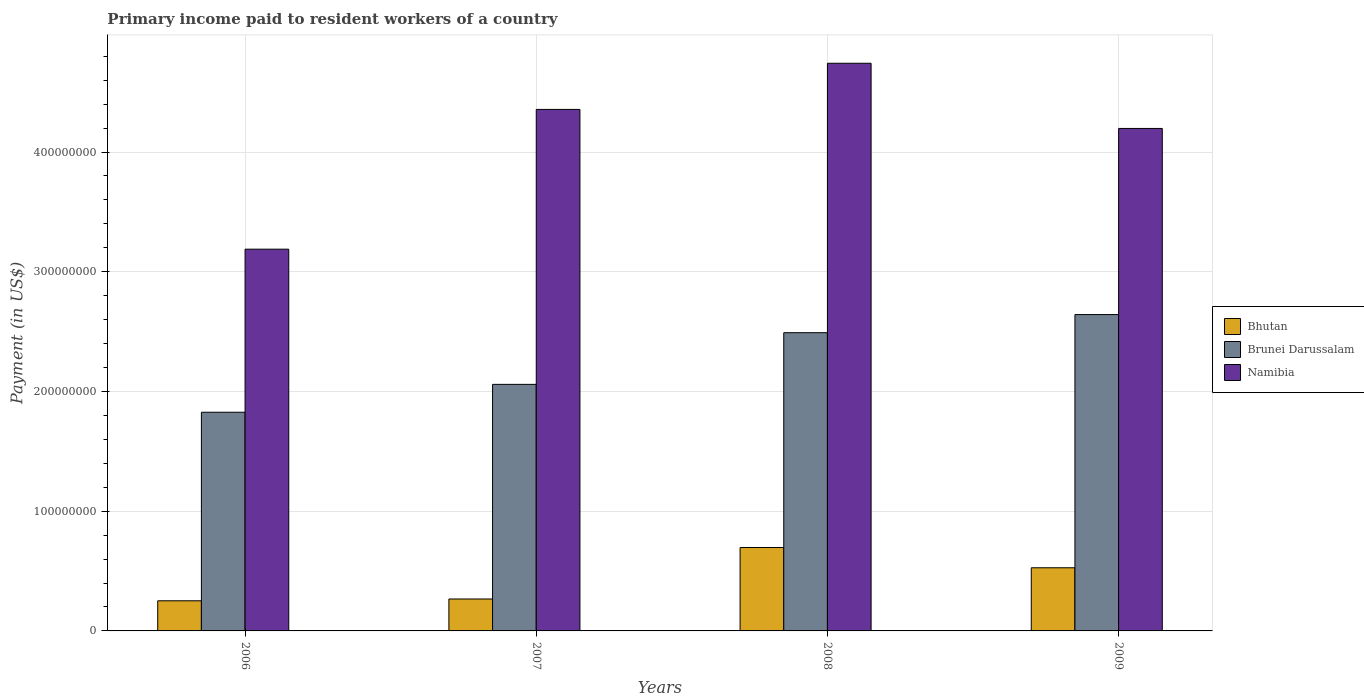How many groups of bars are there?
Keep it short and to the point. 4. Are the number of bars on each tick of the X-axis equal?
Give a very brief answer. Yes. How many bars are there on the 3rd tick from the right?
Your answer should be very brief. 3. In how many cases, is the number of bars for a given year not equal to the number of legend labels?
Your response must be concise. 0. What is the amount paid to workers in Bhutan in 2009?
Provide a short and direct response. 5.27e+07. Across all years, what is the maximum amount paid to workers in Bhutan?
Ensure brevity in your answer.  6.97e+07. Across all years, what is the minimum amount paid to workers in Bhutan?
Make the answer very short. 2.52e+07. What is the total amount paid to workers in Brunei Darussalam in the graph?
Keep it short and to the point. 9.02e+08. What is the difference between the amount paid to workers in Namibia in 2007 and that in 2009?
Keep it short and to the point. 1.59e+07. What is the difference between the amount paid to workers in Bhutan in 2007 and the amount paid to workers in Brunei Darussalam in 2008?
Give a very brief answer. -2.22e+08. What is the average amount paid to workers in Namibia per year?
Your answer should be compact. 4.12e+08. In the year 2007, what is the difference between the amount paid to workers in Bhutan and amount paid to workers in Brunei Darussalam?
Ensure brevity in your answer.  -1.79e+08. In how many years, is the amount paid to workers in Namibia greater than 380000000 US$?
Make the answer very short. 3. What is the ratio of the amount paid to workers in Brunei Darussalam in 2007 to that in 2008?
Provide a short and direct response. 0.83. Is the amount paid to workers in Brunei Darussalam in 2008 less than that in 2009?
Offer a very short reply. Yes. Is the difference between the amount paid to workers in Bhutan in 2006 and 2009 greater than the difference between the amount paid to workers in Brunei Darussalam in 2006 and 2009?
Make the answer very short. Yes. What is the difference between the highest and the second highest amount paid to workers in Namibia?
Your answer should be very brief. 3.86e+07. What is the difference between the highest and the lowest amount paid to workers in Bhutan?
Keep it short and to the point. 4.45e+07. What does the 3rd bar from the left in 2009 represents?
Offer a very short reply. Namibia. What does the 1st bar from the right in 2008 represents?
Your response must be concise. Namibia. Is it the case that in every year, the sum of the amount paid to workers in Namibia and amount paid to workers in Bhutan is greater than the amount paid to workers in Brunei Darussalam?
Provide a succinct answer. Yes. Are all the bars in the graph horizontal?
Make the answer very short. No. How many years are there in the graph?
Your answer should be very brief. 4. What is the difference between two consecutive major ticks on the Y-axis?
Provide a succinct answer. 1.00e+08. Does the graph contain any zero values?
Your response must be concise. No. Does the graph contain grids?
Your answer should be very brief. Yes. How many legend labels are there?
Keep it short and to the point. 3. What is the title of the graph?
Give a very brief answer. Primary income paid to resident workers of a country. What is the label or title of the X-axis?
Your answer should be compact. Years. What is the label or title of the Y-axis?
Give a very brief answer. Payment (in US$). What is the Payment (in US$) of Bhutan in 2006?
Offer a terse response. 2.52e+07. What is the Payment (in US$) in Brunei Darussalam in 2006?
Offer a terse response. 1.83e+08. What is the Payment (in US$) in Namibia in 2006?
Provide a succinct answer. 3.19e+08. What is the Payment (in US$) in Bhutan in 2007?
Keep it short and to the point. 2.67e+07. What is the Payment (in US$) of Brunei Darussalam in 2007?
Keep it short and to the point. 2.06e+08. What is the Payment (in US$) in Namibia in 2007?
Offer a very short reply. 4.36e+08. What is the Payment (in US$) of Bhutan in 2008?
Offer a terse response. 6.97e+07. What is the Payment (in US$) of Brunei Darussalam in 2008?
Make the answer very short. 2.49e+08. What is the Payment (in US$) of Namibia in 2008?
Make the answer very short. 4.74e+08. What is the Payment (in US$) of Bhutan in 2009?
Keep it short and to the point. 5.27e+07. What is the Payment (in US$) in Brunei Darussalam in 2009?
Offer a terse response. 2.64e+08. What is the Payment (in US$) in Namibia in 2009?
Make the answer very short. 4.20e+08. Across all years, what is the maximum Payment (in US$) of Bhutan?
Your answer should be very brief. 6.97e+07. Across all years, what is the maximum Payment (in US$) of Brunei Darussalam?
Provide a short and direct response. 2.64e+08. Across all years, what is the maximum Payment (in US$) in Namibia?
Your answer should be very brief. 4.74e+08. Across all years, what is the minimum Payment (in US$) in Bhutan?
Make the answer very short. 2.52e+07. Across all years, what is the minimum Payment (in US$) of Brunei Darussalam?
Your answer should be very brief. 1.83e+08. Across all years, what is the minimum Payment (in US$) in Namibia?
Your response must be concise. 3.19e+08. What is the total Payment (in US$) in Bhutan in the graph?
Your answer should be compact. 1.74e+08. What is the total Payment (in US$) of Brunei Darussalam in the graph?
Provide a short and direct response. 9.02e+08. What is the total Payment (in US$) in Namibia in the graph?
Keep it short and to the point. 1.65e+09. What is the difference between the Payment (in US$) in Bhutan in 2006 and that in 2007?
Your answer should be compact. -1.50e+06. What is the difference between the Payment (in US$) of Brunei Darussalam in 2006 and that in 2007?
Give a very brief answer. -2.33e+07. What is the difference between the Payment (in US$) in Namibia in 2006 and that in 2007?
Ensure brevity in your answer.  -1.17e+08. What is the difference between the Payment (in US$) of Bhutan in 2006 and that in 2008?
Offer a terse response. -4.45e+07. What is the difference between the Payment (in US$) of Brunei Darussalam in 2006 and that in 2008?
Provide a succinct answer. -6.64e+07. What is the difference between the Payment (in US$) in Namibia in 2006 and that in 2008?
Your answer should be compact. -1.55e+08. What is the difference between the Payment (in US$) in Bhutan in 2006 and that in 2009?
Provide a short and direct response. -2.76e+07. What is the difference between the Payment (in US$) in Brunei Darussalam in 2006 and that in 2009?
Give a very brief answer. -8.16e+07. What is the difference between the Payment (in US$) of Namibia in 2006 and that in 2009?
Ensure brevity in your answer.  -1.01e+08. What is the difference between the Payment (in US$) of Bhutan in 2007 and that in 2008?
Your answer should be compact. -4.30e+07. What is the difference between the Payment (in US$) of Brunei Darussalam in 2007 and that in 2008?
Your response must be concise. -4.32e+07. What is the difference between the Payment (in US$) of Namibia in 2007 and that in 2008?
Your answer should be very brief. -3.86e+07. What is the difference between the Payment (in US$) of Bhutan in 2007 and that in 2009?
Offer a very short reply. -2.61e+07. What is the difference between the Payment (in US$) of Brunei Darussalam in 2007 and that in 2009?
Make the answer very short. -5.83e+07. What is the difference between the Payment (in US$) in Namibia in 2007 and that in 2009?
Offer a terse response. 1.59e+07. What is the difference between the Payment (in US$) of Bhutan in 2008 and that in 2009?
Give a very brief answer. 1.69e+07. What is the difference between the Payment (in US$) in Brunei Darussalam in 2008 and that in 2009?
Ensure brevity in your answer.  -1.51e+07. What is the difference between the Payment (in US$) in Namibia in 2008 and that in 2009?
Offer a terse response. 5.45e+07. What is the difference between the Payment (in US$) of Bhutan in 2006 and the Payment (in US$) of Brunei Darussalam in 2007?
Your answer should be very brief. -1.81e+08. What is the difference between the Payment (in US$) of Bhutan in 2006 and the Payment (in US$) of Namibia in 2007?
Offer a terse response. -4.10e+08. What is the difference between the Payment (in US$) of Brunei Darussalam in 2006 and the Payment (in US$) of Namibia in 2007?
Offer a very short reply. -2.53e+08. What is the difference between the Payment (in US$) of Bhutan in 2006 and the Payment (in US$) of Brunei Darussalam in 2008?
Ensure brevity in your answer.  -2.24e+08. What is the difference between the Payment (in US$) of Bhutan in 2006 and the Payment (in US$) of Namibia in 2008?
Provide a succinct answer. -4.49e+08. What is the difference between the Payment (in US$) in Brunei Darussalam in 2006 and the Payment (in US$) in Namibia in 2008?
Keep it short and to the point. -2.92e+08. What is the difference between the Payment (in US$) of Bhutan in 2006 and the Payment (in US$) of Brunei Darussalam in 2009?
Provide a short and direct response. -2.39e+08. What is the difference between the Payment (in US$) in Bhutan in 2006 and the Payment (in US$) in Namibia in 2009?
Provide a succinct answer. -3.95e+08. What is the difference between the Payment (in US$) of Brunei Darussalam in 2006 and the Payment (in US$) of Namibia in 2009?
Ensure brevity in your answer.  -2.37e+08. What is the difference between the Payment (in US$) of Bhutan in 2007 and the Payment (in US$) of Brunei Darussalam in 2008?
Your response must be concise. -2.22e+08. What is the difference between the Payment (in US$) in Bhutan in 2007 and the Payment (in US$) in Namibia in 2008?
Your response must be concise. -4.47e+08. What is the difference between the Payment (in US$) of Brunei Darussalam in 2007 and the Payment (in US$) of Namibia in 2008?
Make the answer very short. -2.68e+08. What is the difference between the Payment (in US$) of Bhutan in 2007 and the Payment (in US$) of Brunei Darussalam in 2009?
Make the answer very short. -2.38e+08. What is the difference between the Payment (in US$) in Bhutan in 2007 and the Payment (in US$) in Namibia in 2009?
Your response must be concise. -3.93e+08. What is the difference between the Payment (in US$) in Brunei Darussalam in 2007 and the Payment (in US$) in Namibia in 2009?
Provide a succinct answer. -2.14e+08. What is the difference between the Payment (in US$) in Bhutan in 2008 and the Payment (in US$) in Brunei Darussalam in 2009?
Your response must be concise. -1.95e+08. What is the difference between the Payment (in US$) in Bhutan in 2008 and the Payment (in US$) in Namibia in 2009?
Offer a terse response. -3.50e+08. What is the difference between the Payment (in US$) of Brunei Darussalam in 2008 and the Payment (in US$) of Namibia in 2009?
Offer a very short reply. -1.71e+08. What is the average Payment (in US$) in Bhutan per year?
Offer a terse response. 4.36e+07. What is the average Payment (in US$) of Brunei Darussalam per year?
Provide a succinct answer. 2.25e+08. What is the average Payment (in US$) in Namibia per year?
Make the answer very short. 4.12e+08. In the year 2006, what is the difference between the Payment (in US$) in Bhutan and Payment (in US$) in Brunei Darussalam?
Your answer should be very brief. -1.57e+08. In the year 2006, what is the difference between the Payment (in US$) in Bhutan and Payment (in US$) in Namibia?
Offer a very short reply. -2.94e+08. In the year 2006, what is the difference between the Payment (in US$) of Brunei Darussalam and Payment (in US$) of Namibia?
Your response must be concise. -1.36e+08. In the year 2007, what is the difference between the Payment (in US$) in Bhutan and Payment (in US$) in Brunei Darussalam?
Offer a very short reply. -1.79e+08. In the year 2007, what is the difference between the Payment (in US$) in Bhutan and Payment (in US$) in Namibia?
Give a very brief answer. -4.09e+08. In the year 2007, what is the difference between the Payment (in US$) in Brunei Darussalam and Payment (in US$) in Namibia?
Ensure brevity in your answer.  -2.30e+08. In the year 2008, what is the difference between the Payment (in US$) of Bhutan and Payment (in US$) of Brunei Darussalam?
Your answer should be very brief. -1.79e+08. In the year 2008, what is the difference between the Payment (in US$) of Bhutan and Payment (in US$) of Namibia?
Keep it short and to the point. -4.05e+08. In the year 2008, what is the difference between the Payment (in US$) of Brunei Darussalam and Payment (in US$) of Namibia?
Give a very brief answer. -2.25e+08. In the year 2009, what is the difference between the Payment (in US$) in Bhutan and Payment (in US$) in Brunei Darussalam?
Your response must be concise. -2.12e+08. In the year 2009, what is the difference between the Payment (in US$) in Bhutan and Payment (in US$) in Namibia?
Your answer should be very brief. -3.67e+08. In the year 2009, what is the difference between the Payment (in US$) in Brunei Darussalam and Payment (in US$) in Namibia?
Your answer should be very brief. -1.55e+08. What is the ratio of the Payment (in US$) of Bhutan in 2006 to that in 2007?
Give a very brief answer. 0.94. What is the ratio of the Payment (in US$) of Brunei Darussalam in 2006 to that in 2007?
Your answer should be very brief. 0.89. What is the ratio of the Payment (in US$) of Namibia in 2006 to that in 2007?
Your answer should be very brief. 0.73. What is the ratio of the Payment (in US$) of Bhutan in 2006 to that in 2008?
Your answer should be very brief. 0.36. What is the ratio of the Payment (in US$) of Brunei Darussalam in 2006 to that in 2008?
Make the answer very short. 0.73. What is the ratio of the Payment (in US$) in Namibia in 2006 to that in 2008?
Ensure brevity in your answer.  0.67. What is the ratio of the Payment (in US$) of Bhutan in 2006 to that in 2009?
Your answer should be very brief. 0.48. What is the ratio of the Payment (in US$) in Brunei Darussalam in 2006 to that in 2009?
Offer a very short reply. 0.69. What is the ratio of the Payment (in US$) of Namibia in 2006 to that in 2009?
Make the answer very short. 0.76. What is the ratio of the Payment (in US$) in Bhutan in 2007 to that in 2008?
Provide a succinct answer. 0.38. What is the ratio of the Payment (in US$) in Brunei Darussalam in 2007 to that in 2008?
Provide a short and direct response. 0.83. What is the ratio of the Payment (in US$) of Namibia in 2007 to that in 2008?
Ensure brevity in your answer.  0.92. What is the ratio of the Payment (in US$) of Bhutan in 2007 to that in 2009?
Provide a short and direct response. 0.51. What is the ratio of the Payment (in US$) in Brunei Darussalam in 2007 to that in 2009?
Ensure brevity in your answer.  0.78. What is the ratio of the Payment (in US$) in Namibia in 2007 to that in 2009?
Your answer should be compact. 1.04. What is the ratio of the Payment (in US$) in Bhutan in 2008 to that in 2009?
Keep it short and to the point. 1.32. What is the ratio of the Payment (in US$) in Brunei Darussalam in 2008 to that in 2009?
Your answer should be very brief. 0.94. What is the ratio of the Payment (in US$) in Namibia in 2008 to that in 2009?
Provide a short and direct response. 1.13. What is the difference between the highest and the second highest Payment (in US$) of Bhutan?
Make the answer very short. 1.69e+07. What is the difference between the highest and the second highest Payment (in US$) in Brunei Darussalam?
Give a very brief answer. 1.51e+07. What is the difference between the highest and the second highest Payment (in US$) in Namibia?
Your response must be concise. 3.86e+07. What is the difference between the highest and the lowest Payment (in US$) in Bhutan?
Offer a terse response. 4.45e+07. What is the difference between the highest and the lowest Payment (in US$) in Brunei Darussalam?
Make the answer very short. 8.16e+07. What is the difference between the highest and the lowest Payment (in US$) in Namibia?
Provide a short and direct response. 1.55e+08. 